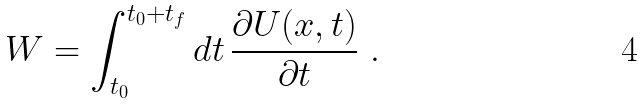Convert formula to latex. <formula><loc_0><loc_0><loc_500><loc_500>W = \int _ { t _ { 0 } } ^ { t _ { 0 } + t _ { f } } d t \, \frac { \partial U ( x , t ) } { \partial t } \ .</formula> 